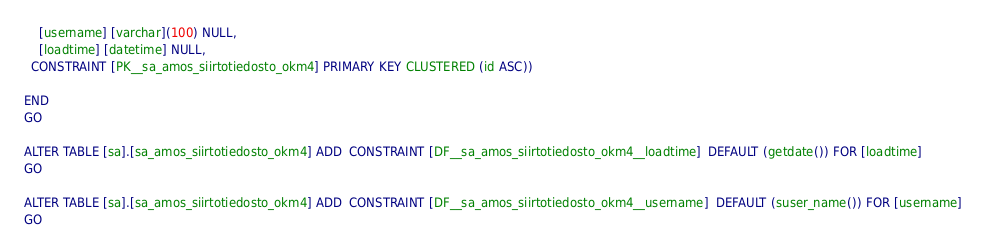<code> <loc_0><loc_0><loc_500><loc_500><_SQL_>	[username] [varchar](100) NULL,
	[loadtime] [datetime] NULL,
  CONSTRAINT [PK__sa_amos_siirtotiedosto_okm4] PRIMARY KEY CLUSTERED (id ASC))

END
GO

ALTER TABLE [sa].[sa_amos_siirtotiedosto_okm4] ADD  CONSTRAINT [DF__sa_amos_siirtotiedosto_okm4__loadtime]  DEFAULT (getdate()) FOR [loadtime]
GO

ALTER TABLE [sa].[sa_amos_siirtotiedosto_okm4] ADD  CONSTRAINT [DF__sa_amos_siirtotiedosto_okm4__username]  DEFAULT (suser_name()) FOR [username]
GO
</code> 